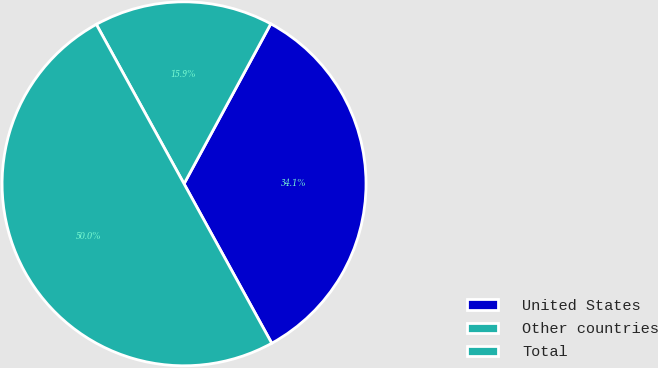<chart> <loc_0><loc_0><loc_500><loc_500><pie_chart><fcel>United States<fcel>Other countries<fcel>Total<nl><fcel>34.09%<fcel>15.91%<fcel>50.0%<nl></chart> 